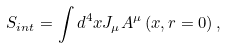Convert formula to latex. <formula><loc_0><loc_0><loc_500><loc_500>S _ { i n t } = \int d ^ { 4 } x J _ { \mu } A ^ { \mu } \left ( x , r = 0 \right ) ,</formula> 